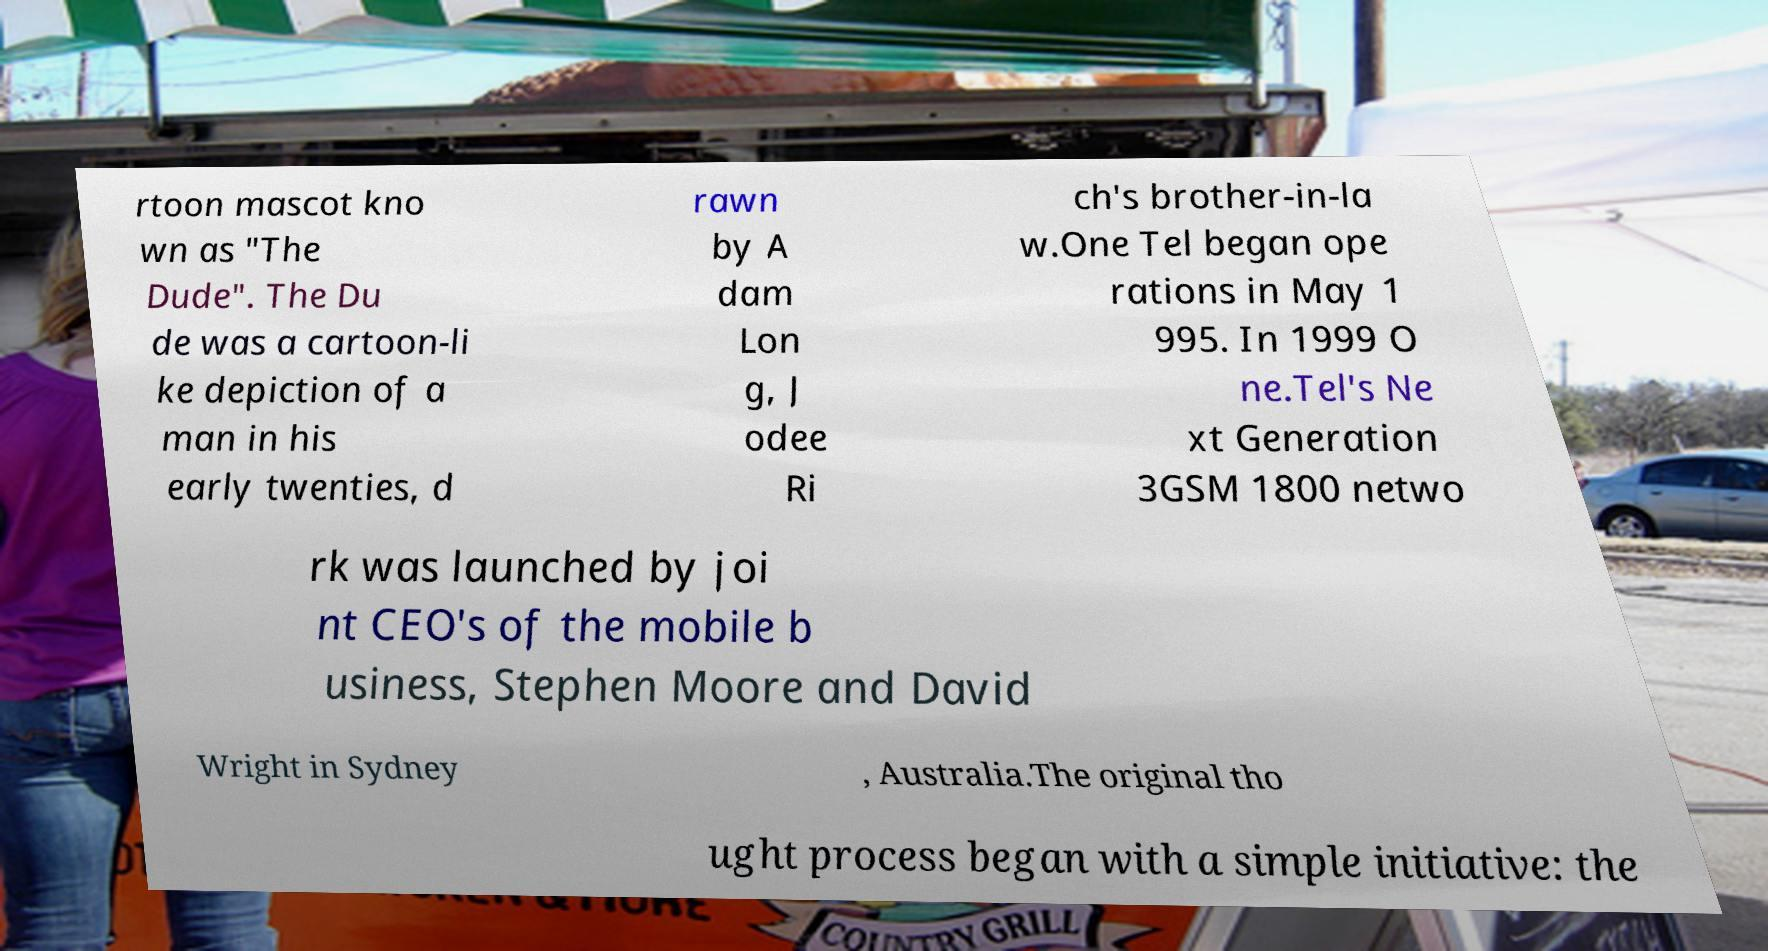Please read and relay the text visible in this image. What does it say? rtoon mascot kno wn as "The Dude". The Du de was a cartoon-li ke depiction of a man in his early twenties, d rawn by A dam Lon g, J odee Ri ch's brother-in-la w.One Tel began ope rations in May 1 995. In 1999 O ne.Tel's Ne xt Generation 3GSM 1800 netwo rk was launched by joi nt CEO's of the mobile b usiness, Stephen Moore and David Wright in Sydney , Australia.The original tho ught process began with a simple initiative: the 